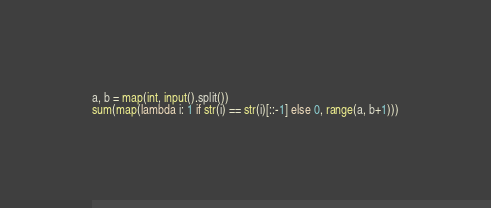<code> <loc_0><loc_0><loc_500><loc_500><_Python_>a, b = map(int, input().split())
sum(map(lambda i: 1 if str(i) == str(i)[::-1] else 0, range(a, b+1)))</code> 